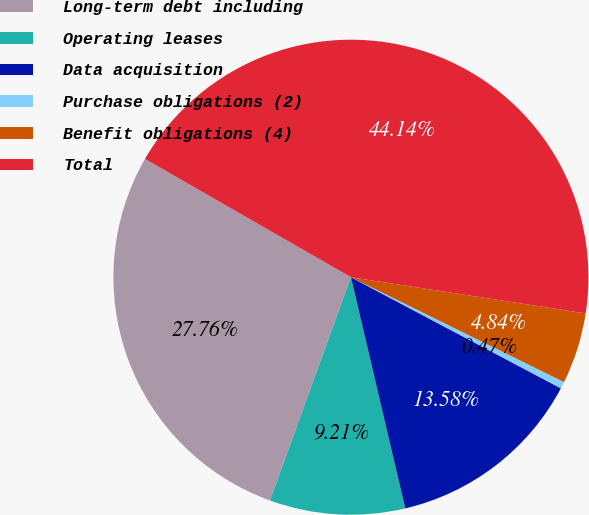Convert chart. <chart><loc_0><loc_0><loc_500><loc_500><pie_chart><fcel>Long-term debt including<fcel>Operating leases<fcel>Data acquisition<fcel>Purchase obligations (2)<fcel>Benefit obligations (4)<fcel>Total<nl><fcel>27.76%<fcel>9.21%<fcel>13.58%<fcel>0.47%<fcel>4.84%<fcel>44.14%<nl></chart> 